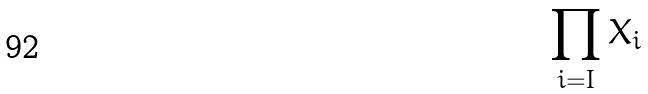<formula> <loc_0><loc_0><loc_500><loc_500>\prod _ { i = I } X _ { i }</formula> 